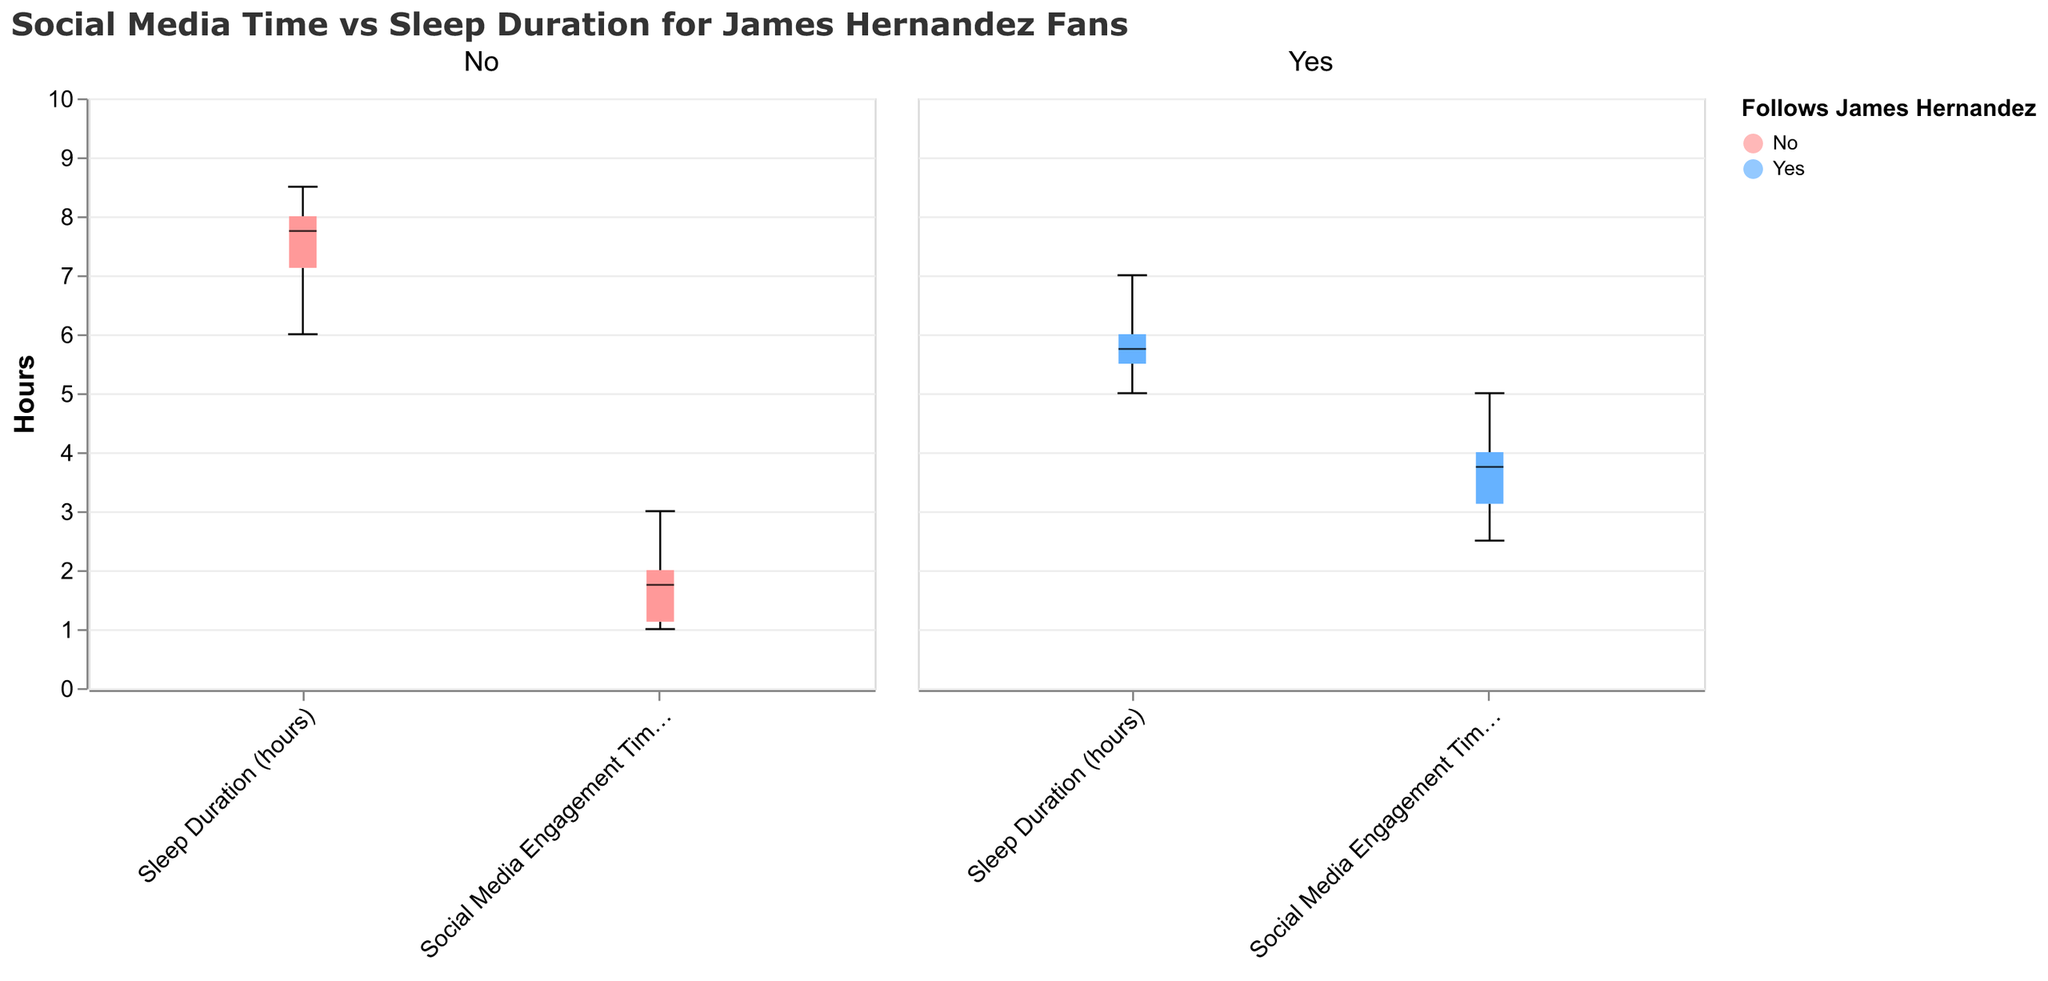What is the title of the figure? The title is located at the top of the figure and is written in larger font compared to other text elements.
Answer: Social Media Time vs Sleep Duration for James Hernandez Fans What are the two variables being compared in this figure? The variables are labeled on the x-axis and represent the categories within each group.
Answer: Social Media Engagement Time (hours) and Sleep Duration (hours) How does the median Sleep Duration compare between teens who follow James Hernandez and those who do not? Locate the median line within the boxplots for Sleep Duration for both groups and compare the values.
Answer: Teens who follow James Hernandez have a lower median Sleep Duration compared to those who do not Which group shows a wider range in Social Media Engagement Time? Observe the length of the boxplots along the y-axis for Social Media Engagement Time, noting which boxplot stretches further.
Answer: Teens who follow James Hernandez What is the maximum Sleep Duration observed in the group that follows James Hernandez? The maximum value corresponds to the top whisker of the boxplot for Sleep Duration in the "Yes" group.
Answer: 7 hours For which variable do teens who do not follow James Hernandez show a greater interquartile range (IQR)? Compare the height of the boxes (the distance between the top and bottom of the box) for both variables in the "No" group.
Answer: Sleep Duration (hours) What is the median Social Media Engagement Time for teens who do not follow James Hernandez? The median Social Media Engagement Time is represented by the line inside the boxplot for Social Media Engagement Time in the "No" group.
Answer: 2 hours Is there a group with any outliers in their Social Media Engagement Time, and if so, which group? Check for any individual data points that fall outside the whiskers of the boxplots in both groups for Social Media Engagement Time.
Answer: No, there are no outliers 